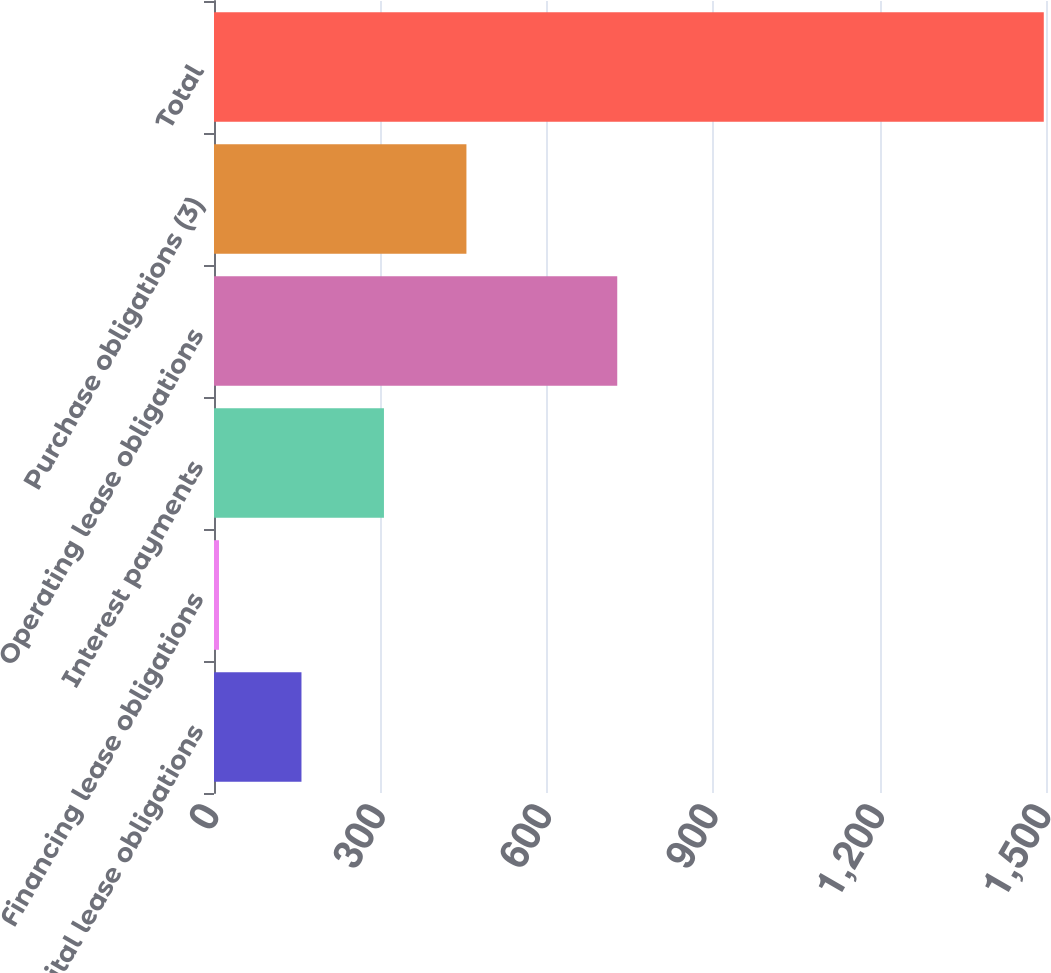Convert chart to OTSL. <chart><loc_0><loc_0><loc_500><loc_500><bar_chart><fcel>Capital lease obligations<fcel>Financing lease obligations<fcel>Interest payments<fcel>Operating lease obligations<fcel>Purchase obligations (3)<fcel>Total<nl><fcel>157.7<fcel>9<fcel>306.4<fcel>727<fcel>455.1<fcel>1496<nl></chart> 